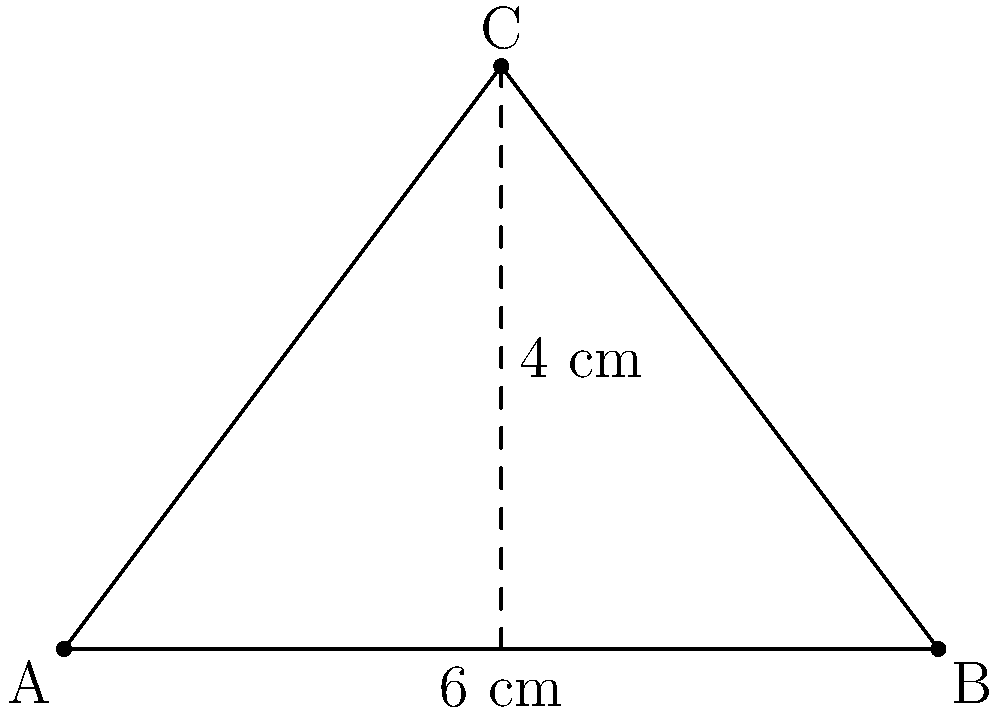You're planning to plant a new crop in a triangular section of your farm. The base of this section measures 6 cm on your scaled map, and its height is 4 cm. What is the actual area of this triangular plot if 1 cm on the map represents 100 meters in real life? To solve this problem, let's follow these steps:

1) First, we need to calculate the area of the triangle on the map:
   The formula for the area of a triangle is: $A = \frac{1}{2} \times base \times height$
   
   $A = \frac{1}{2} \times 6 \text{ cm} \times 4 \text{ cm} = 12 \text{ cm}^2$

2) Now, we need to convert this to the real-life scale:
   The scale is 1 cm : 100 m, so 1 cm² on the map represents $(100 \text{ m})^2 = 10,000 \text{ m}^2$

3) Therefore, the real area is:
   $12 \text{ cm}^2 \times 10,000 \text{ m}^2/\text{cm}^2 = 120,000 \text{ m}^2$

4) To convert this to hectares (a common unit for farmland):
   $120,000 \text{ m}^2 = 12 \text{ hectares}$ (since 1 hectare = 10,000 m²)

Thus, the actual area of the triangular plot is 12 hectares.
Answer: 12 hectares 